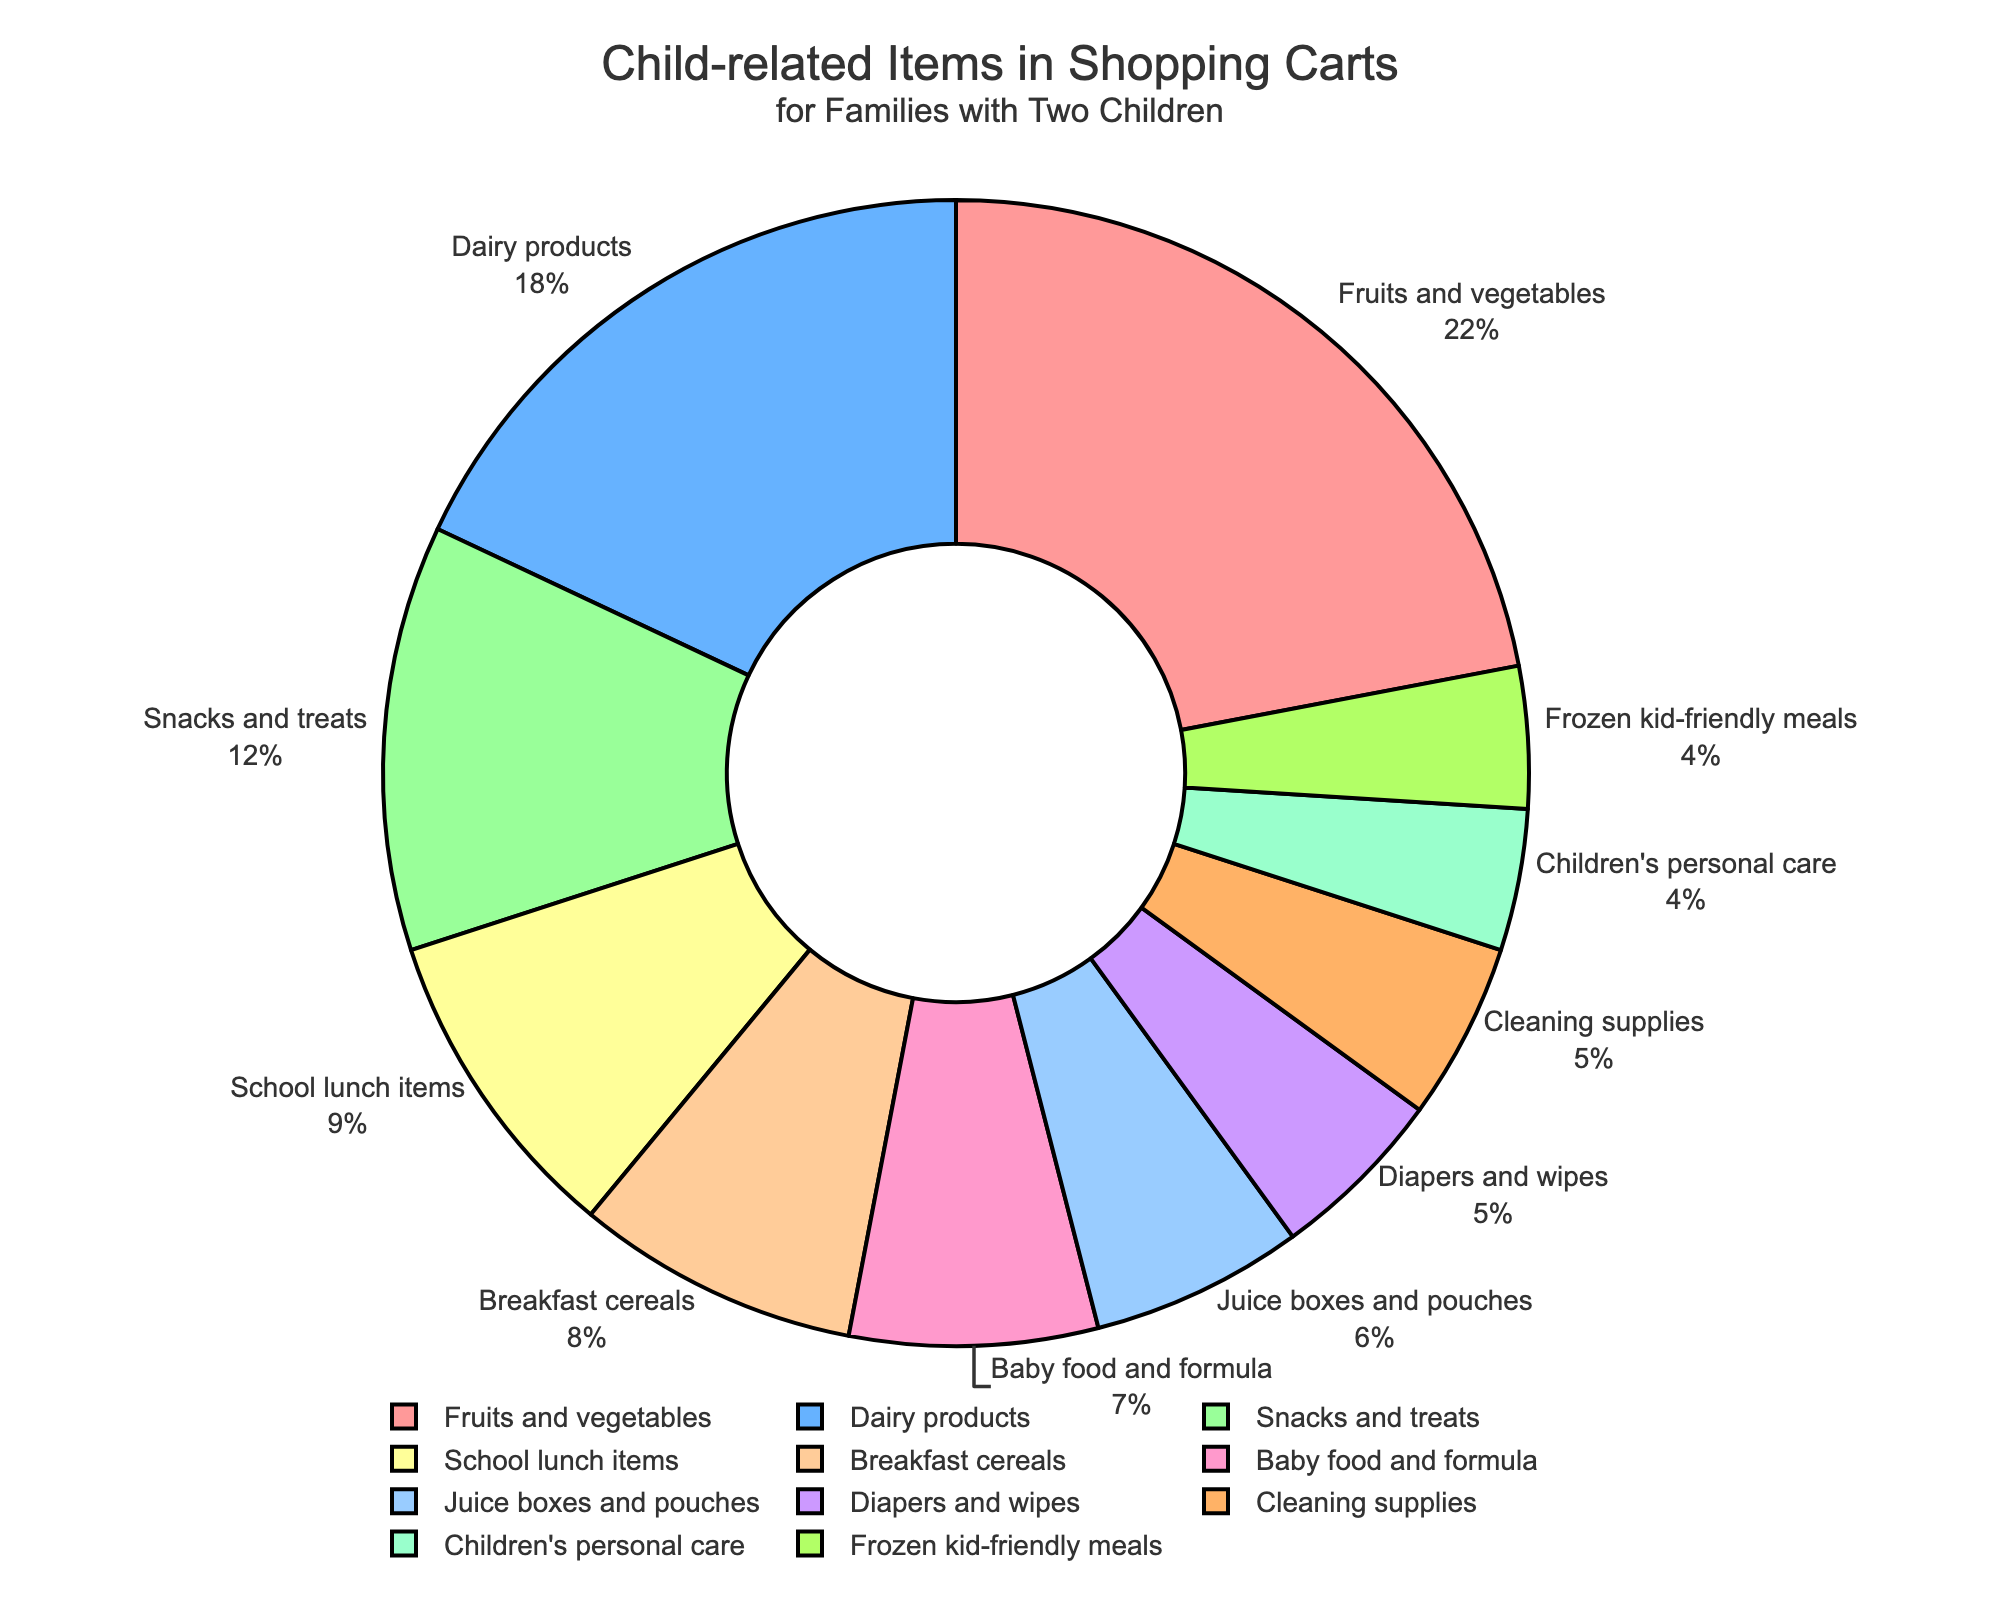Which category occupies the largest portion of the pie chart? By looking at the slices of the pie chart, the largest slice is usually distinguishable by its size. Here, "Fruits and vegetables" occupies the largest portion.
Answer: Fruits and vegetables How much greater is the percentage for Dairy products compared to Juice boxes and pouches? The percentage for Dairy products is 18%, and for Juice boxes and pouches, it is 6%. Subtract 6 from 18 to get the difference.
Answer: 12% What is the combined percentage of Snacks and treats and Breakfast cereals? The percentage for Snacks and treats is 12%, and for Breakfast cereals, it is 8%. Add these two percentages together: 12 + 8 = 20%.
Answer: 20% Which category has a smaller proportion, Cleaning supplies or Children's personal care? By comparing the sizes of the slices for Cleaning supplies and Children's personal care directly from the pie chart, Cleaning supplies at 5% is larger than Children's personal care at 4%.
Answer: Children's personal care What is the sum of categories that are less than 10% each? Sum up the percentages of categories that are less than 10% each: Breakfast cereals (8%), Baby food and formula (7%), Juice boxes and pouches (6%), School lunch items (9%), Diapers and wipes (5%), Children's personal care (4%), Frozen kid-friendly meals (4%), Cleaning supplies (5%). 8 + 7 + 6 + 9 + 5 + 4 + 4 + 5 = 48%.
Answer: 48% What percentage more does Fruits and vegetables have over Diapers and wipes? The percentage for Fruits and vegetables is 22%, and for Diapers and wipes, it is 5%. Subtract 5 from 22 to get the difference, which is 17%.
Answer: 17% How many categories fall within the 5-10% range? By checking each category's percentage, the ones that fall within the 5-10% range are: School lunch items (9%), Juice boxes and pouches (6%), Baby food and formula (7%), Diapers and wipes (5%), and Cleaning supplies (5%). There are a total of 5 categories.
Answer: 5 What is the total combined percentage of the top three categories? The top three categories by percentage are: Fruits and vegetables (22%), Dairy products (18%), and Snacks and treats (12%). Add these three percentages together: 22 + 18 + 12 = 52%.
Answer: 52% Which category has the smallest portion in the pie chart? By observing the pie chart, the slice representing the smallest portion is "Children's personal care" at 4%.
Answer: Children's personal care 